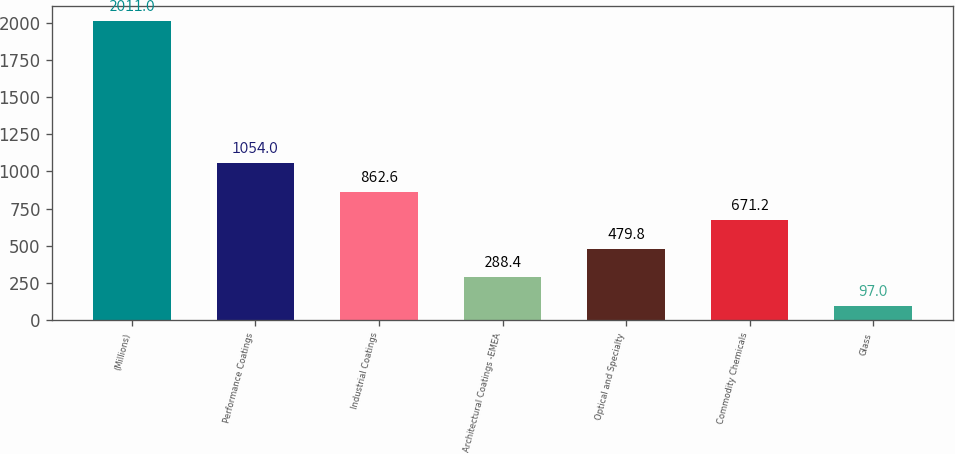Convert chart. <chart><loc_0><loc_0><loc_500><loc_500><bar_chart><fcel>(Millions)<fcel>Performance Coatings<fcel>Industrial Coatings<fcel>Architectural Coatings -EMEA<fcel>Optical and Specialty<fcel>Commodity Chemicals<fcel>Glass<nl><fcel>2011<fcel>1054<fcel>862.6<fcel>288.4<fcel>479.8<fcel>671.2<fcel>97<nl></chart> 